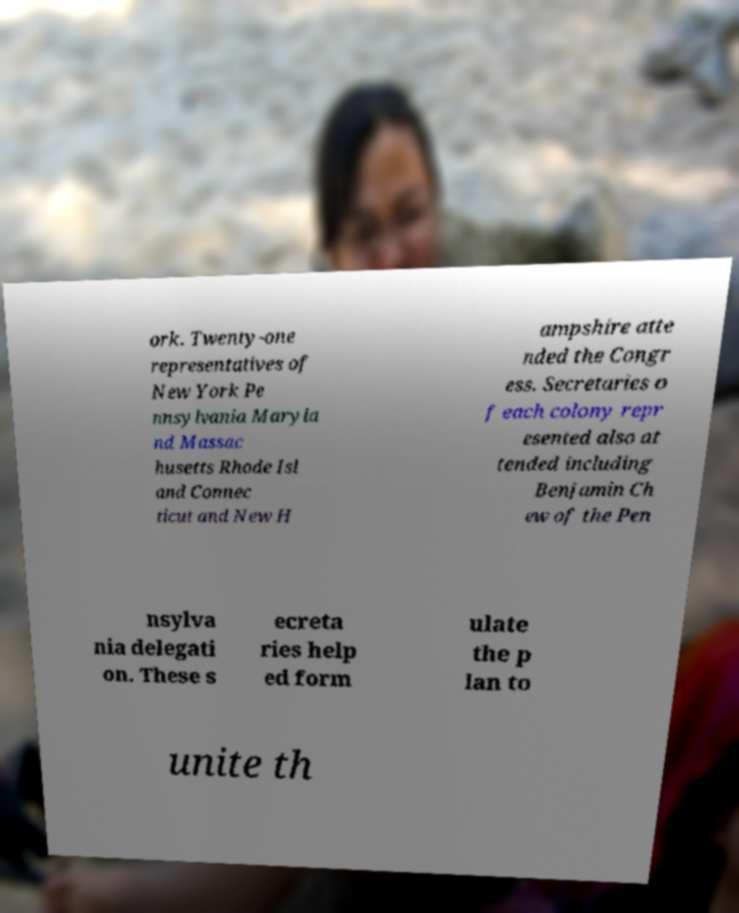Could you extract and type out the text from this image? ork. Twenty-one representatives of New York Pe nnsylvania Maryla nd Massac husetts Rhode Isl and Connec ticut and New H ampshire atte nded the Congr ess. Secretaries o f each colony repr esented also at tended including Benjamin Ch ew of the Pen nsylva nia delegati on. These s ecreta ries help ed form ulate the p lan to unite th 